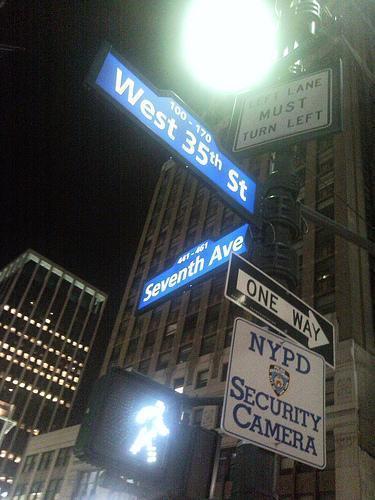How many signs are on the post?
Give a very brief answer. 5. 